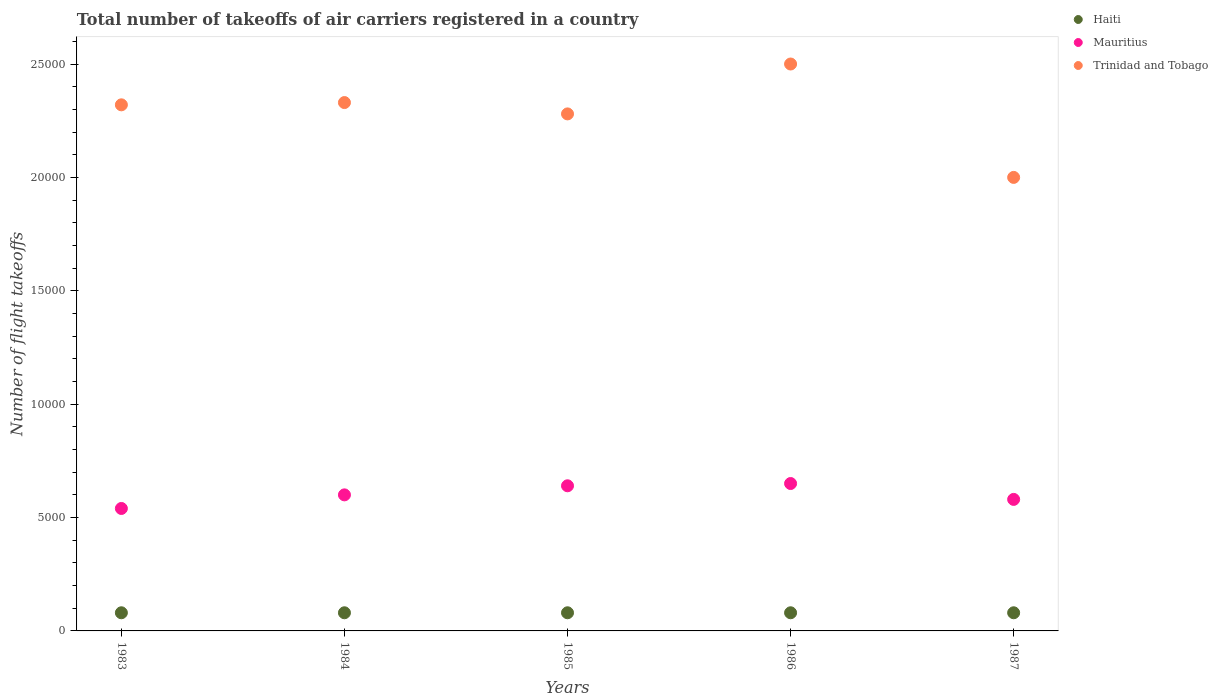How many different coloured dotlines are there?
Give a very brief answer. 3. Is the number of dotlines equal to the number of legend labels?
Your response must be concise. Yes. What is the total number of flight takeoffs in Mauritius in 1986?
Provide a short and direct response. 6500. Across all years, what is the maximum total number of flight takeoffs in Haiti?
Give a very brief answer. 800. Across all years, what is the minimum total number of flight takeoffs in Haiti?
Make the answer very short. 800. In which year was the total number of flight takeoffs in Trinidad and Tobago maximum?
Provide a succinct answer. 1986. What is the total total number of flight takeoffs in Trinidad and Tobago in the graph?
Offer a terse response. 1.14e+05. What is the difference between the total number of flight takeoffs in Haiti in 1985 and the total number of flight takeoffs in Mauritius in 1986?
Your response must be concise. -5700. What is the average total number of flight takeoffs in Mauritius per year?
Offer a terse response. 6020. In the year 1983, what is the difference between the total number of flight takeoffs in Mauritius and total number of flight takeoffs in Haiti?
Give a very brief answer. 4600. What is the ratio of the total number of flight takeoffs in Trinidad and Tobago in 1985 to that in 1987?
Your answer should be compact. 1.14. Is the sum of the total number of flight takeoffs in Haiti in 1984 and 1986 greater than the maximum total number of flight takeoffs in Mauritius across all years?
Offer a very short reply. No. Does the total number of flight takeoffs in Haiti monotonically increase over the years?
Your response must be concise. No. Is the total number of flight takeoffs in Haiti strictly greater than the total number of flight takeoffs in Trinidad and Tobago over the years?
Keep it short and to the point. No. Is the total number of flight takeoffs in Trinidad and Tobago strictly less than the total number of flight takeoffs in Mauritius over the years?
Keep it short and to the point. No. How many years are there in the graph?
Make the answer very short. 5. What is the difference between two consecutive major ticks on the Y-axis?
Your response must be concise. 5000. Does the graph contain grids?
Make the answer very short. No. How many legend labels are there?
Your response must be concise. 3. How are the legend labels stacked?
Your answer should be very brief. Vertical. What is the title of the graph?
Offer a terse response. Total number of takeoffs of air carriers registered in a country. What is the label or title of the X-axis?
Provide a short and direct response. Years. What is the label or title of the Y-axis?
Keep it short and to the point. Number of flight takeoffs. What is the Number of flight takeoffs in Haiti in 1983?
Provide a succinct answer. 800. What is the Number of flight takeoffs of Mauritius in 1983?
Your response must be concise. 5400. What is the Number of flight takeoffs of Trinidad and Tobago in 1983?
Offer a very short reply. 2.32e+04. What is the Number of flight takeoffs in Haiti in 1984?
Your response must be concise. 800. What is the Number of flight takeoffs in Mauritius in 1984?
Your response must be concise. 6000. What is the Number of flight takeoffs of Trinidad and Tobago in 1984?
Your response must be concise. 2.33e+04. What is the Number of flight takeoffs in Haiti in 1985?
Offer a very short reply. 800. What is the Number of flight takeoffs of Mauritius in 1985?
Keep it short and to the point. 6400. What is the Number of flight takeoffs of Trinidad and Tobago in 1985?
Your response must be concise. 2.28e+04. What is the Number of flight takeoffs of Haiti in 1986?
Provide a succinct answer. 800. What is the Number of flight takeoffs in Mauritius in 1986?
Offer a terse response. 6500. What is the Number of flight takeoffs in Trinidad and Tobago in 1986?
Provide a succinct answer. 2.50e+04. What is the Number of flight takeoffs of Haiti in 1987?
Make the answer very short. 800. What is the Number of flight takeoffs in Mauritius in 1987?
Keep it short and to the point. 5800. What is the Number of flight takeoffs in Trinidad and Tobago in 1987?
Ensure brevity in your answer.  2.00e+04. Across all years, what is the maximum Number of flight takeoffs of Haiti?
Provide a succinct answer. 800. Across all years, what is the maximum Number of flight takeoffs of Mauritius?
Offer a very short reply. 6500. Across all years, what is the maximum Number of flight takeoffs in Trinidad and Tobago?
Your response must be concise. 2.50e+04. Across all years, what is the minimum Number of flight takeoffs in Haiti?
Keep it short and to the point. 800. Across all years, what is the minimum Number of flight takeoffs of Mauritius?
Your answer should be very brief. 5400. Across all years, what is the minimum Number of flight takeoffs of Trinidad and Tobago?
Offer a very short reply. 2.00e+04. What is the total Number of flight takeoffs of Haiti in the graph?
Make the answer very short. 4000. What is the total Number of flight takeoffs in Mauritius in the graph?
Provide a succinct answer. 3.01e+04. What is the total Number of flight takeoffs of Trinidad and Tobago in the graph?
Give a very brief answer. 1.14e+05. What is the difference between the Number of flight takeoffs of Haiti in 1983 and that in 1984?
Offer a very short reply. 0. What is the difference between the Number of flight takeoffs of Mauritius in 1983 and that in 1984?
Your response must be concise. -600. What is the difference between the Number of flight takeoffs of Trinidad and Tobago in 1983 and that in 1984?
Provide a short and direct response. -100. What is the difference between the Number of flight takeoffs in Mauritius in 1983 and that in 1985?
Ensure brevity in your answer.  -1000. What is the difference between the Number of flight takeoffs of Haiti in 1983 and that in 1986?
Your answer should be very brief. 0. What is the difference between the Number of flight takeoffs of Mauritius in 1983 and that in 1986?
Provide a succinct answer. -1100. What is the difference between the Number of flight takeoffs of Trinidad and Tobago in 1983 and that in 1986?
Ensure brevity in your answer.  -1800. What is the difference between the Number of flight takeoffs of Haiti in 1983 and that in 1987?
Give a very brief answer. 0. What is the difference between the Number of flight takeoffs in Mauritius in 1983 and that in 1987?
Give a very brief answer. -400. What is the difference between the Number of flight takeoffs of Trinidad and Tobago in 1983 and that in 1987?
Your answer should be compact. 3200. What is the difference between the Number of flight takeoffs in Mauritius in 1984 and that in 1985?
Provide a short and direct response. -400. What is the difference between the Number of flight takeoffs in Haiti in 1984 and that in 1986?
Offer a very short reply. 0. What is the difference between the Number of flight takeoffs of Mauritius in 1984 and that in 1986?
Offer a very short reply. -500. What is the difference between the Number of flight takeoffs in Trinidad and Tobago in 1984 and that in 1986?
Ensure brevity in your answer.  -1700. What is the difference between the Number of flight takeoffs in Haiti in 1984 and that in 1987?
Offer a terse response. 0. What is the difference between the Number of flight takeoffs in Trinidad and Tobago in 1984 and that in 1987?
Keep it short and to the point. 3300. What is the difference between the Number of flight takeoffs of Haiti in 1985 and that in 1986?
Make the answer very short. 0. What is the difference between the Number of flight takeoffs in Mauritius in 1985 and that in 1986?
Offer a terse response. -100. What is the difference between the Number of flight takeoffs in Trinidad and Tobago in 1985 and that in 1986?
Your answer should be compact. -2200. What is the difference between the Number of flight takeoffs of Mauritius in 1985 and that in 1987?
Your answer should be compact. 600. What is the difference between the Number of flight takeoffs in Trinidad and Tobago in 1985 and that in 1987?
Provide a succinct answer. 2800. What is the difference between the Number of flight takeoffs of Haiti in 1986 and that in 1987?
Provide a succinct answer. 0. What is the difference between the Number of flight takeoffs of Mauritius in 1986 and that in 1987?
Make the answer very short. 700. What is the difference between the Number of flight takeoffs in Trinidad and Tobago in 1986 and that in 1987?
Provide a short and direct response. 5000. What is the difference between the Number of flight takeoffs in Haiti in 1983 and the Number of flight takeoffs in Mauritius in 1984?
Your answer should be very brief. -5200. What is the difference between the Number of flight takeoffs of Haiti in 1983 and the Number of flight takeoffs of Trinidad and Tobago in 1984?
Provide a succinct answer. -2.25e+04. What is the difference between the Number of flight takeoffs of Mauritius in 1983 and the Number of flight takeoffs of Trinidad and Tobago in 1984?
Keep it short and to the point. -1.79e+04. What is the difference between the Number of flight takeoffs of Haiti in 1983 and the Number of flight takeoffs of Mauritius in 1985?
Offer a terse response. -5600. What is the difference between the Number of flight takeoffs of Haiti in 1983 and the Number of flight takeoffs of Trinidad and Tobago in 1985?
Ensure brevity in your answer.  -2.20e+04. What is the difference between the Number of flight takeoffs of Mauritius in 1983 and the Number of flight takeoffs of Trinidad and Tobago in 1985?
Keep it short and to the point. -1.74e+04. What is the difference between the Number of flight takeoffs of Haiti in 1983 and the Number of flight takeoffs of Mauritius in 1986?
Ensure brevity in your answer.  -5700. What is the difference between the Number of flight takeoffs in Haiti in 1983 and the Number of flight takeoffs in Trinidad and Tobago in 1986?
Offer a terse response. -2.42e+04. What is the difference between the Number of flight takeoffs of Mauritius in 1983 and the Number of flight takeoffs of Trinidad and Tobago in 1986?
Your answer should be compact. -1.96e+04. What is the difference between the Number of flight takeoffs of Haiti in 1983 and the Number of flight takeoffs of Mauritius in 1987?
Your answer should be very brief. -5000. What is the difference between the Number of flight takeoffs in Haiti in 1983 and the Number of flight takeoffs in Trinidad and Tobago in 1987?
Your response must be concise. -1.92e+04. What is the difference between the Number of flight takeoffs of Mauritius in 1983 and the Number of flight takeoffs of Trinidad and Tobago in 1987?
Your answer should be very brief. -1.46e+04. What is the difference between the Number of flight takeoffs of Haiti in 1984 and the Number of flight takeoffs of Mauritius in 1985?
Your response must be concise. -5600. What is the difference between the Number of flight takeoffs in Haiti in 1984 and the Number of flight takeoffs in Trinidad and Tobago in 1985?
Offer a very short reply. -2.20e+04. What is the difference between the Number of flight takeoffs in Mauritius in 1984 and the Number of flight takeoffs in Trinidad and Tobago in 1985?
Keep it short and to the point. -1.68e+04. What is the difference between the Number of flight takeoffs in Haiti in 1984 and the Number of flight takeoffs in Mauritius in 1986?
Make the answer very short. -5700. What is the difference between the Number of flight takeoffs in Haiti in 1984 and the Number of flight takeoffs in Trinidad and Tobago in 1986?
Keep it short and to the point. -2.42e+04. What is the difference between the Number of flight takeoffs of Mauritius in 1984 and the Number of flight takeoffs of Trinidad and Tobago in 1986?
Make the answer very short. -1.90e+04. What is the difference between the Number of flight takeoffs of Haiti in 1984 and the Number of flight takeoffs of Mauritius in 1987?
Provide a short and direct response. -5000. What is the difference between the Number of flight takeoffs in Haiti in 1984 and the Number of flight takeoffs in Trinidad and Tobago in 1987?
Offer a very short reply. -1.92e+04. What is the difference between the Number of flight takeoffs in Mauritius in 1984 and the Number of flight takeoffs in Trinidad and Tobago in 1987?
Your answer should be compact. -1.40e+04. What is the difference between the Number of flight takeoffs in Haiti in 1985 and the Number of flight takeoffs in Mauritius in 1986?
Provide a succinct answer. -5700. What is the difference between the Number of flight takeoffs in Haiti in 1985 and the Number of flight takeoffs in Trinidad and Tobago in 1986?
Keep it short and to the point. -2.42e+04. What is the difference between the Number of flight takeoffs of Mauritius in 1985 and the Number of flight takeoffs of Trinidad and Tobago in 1986?
Make the answer very short. -1.86e+04. What is the difference between the Number of flight takeoffs in Haiti in 1985 and the Number of flight takeoffs in Mauritius in 1987?
Provide a succinct answer. -5000. What is the difference between the Number of flight takeoffs of Haiti in 1985 and the Number of flight takeoffs of Trinidad and Tobago in 1987?
Ensure brevity in your answer.  -1.92e+04. What is the difference between the Number of flight takeoffs in Mauritius in 1985 and the Number of flight takeoffs in Trinidad and Tobago in 1987?
Your answer should be very brief. -1.36e+04. What is the difference between the Number of flight takeoffs of Haiti in 1986 and the Number of flight takeoffs of Mauritius in 1987?
Make the answer very short. -5000. What is the difference between the Number of flight takeoffs of Haiti in 1986 and the Number of flight takeoffs of Trinidad and Tobago in 1987?
Give a very brief answer. -1.92e+04. What is the difference between the Number of flight takeoffs in Mauritius in 1986 and the Number of flight takeoffs in Trinidad and Tobago in 1987?
Keep it short and to the point. -1.35e+04. What is the average Number of flight takeoffs of Haiti per year?
Provide a succinct answer. 800. What is the average Number of flight takeoffs of Mauritius per year?
Offer a terse response. 6020. What is the average Number of flight takeoffs of Trinidad and Tobago per year?
Ensure brevity in your answer.  2.29e+04. In the year 1983, what is the difference between the Number of flight takeoffs in Haiti and Number of flight takeoffs in Mauritius?
Your response must be concise. -4600. In the year 1983, what is the difference between the Number of flight takeoffs of Haiti and Number of flight takeoffs of Trinidad and Tobago?
Provide a short and direct response. -2.24e+04. In the year 1983, what is the difference between the Number of flight takeoffs of Mauritius and Number of flight takeoffs of Trinidad and Tobago?
Your response must be concise. -1.78e+04. In the year 1984, what is the difference between the Number of flight takeoffs of Haiti and Number of flight takeoffs of Mauritius?
Your answer should be compact. -5200. In the year 1984, what is the difference between the Number of flight takeoffs of Haiti and Number of flight takeoffs of Trinidad and Tobago?
Your answer should be very brief. -2.25e+04. In the year 1984, what is the difference between the Number of flight takeoffs of Mauritius and Number of flight takeoffs of Trinidad and Tobago?
Ensure brevity in your answer.  -1.73e+04. In the year 1985, what is the difference between the Number of flight takeoffs of Haiti and Number of flight takeoffs of Mauritius?
Give a very brief answer. -5600. In the year 1985, what is the difference between the Number of flight takeoffs in Haiti and Number of flight takeoffs in Trinidad and Tobago?
Provide a succinct answer. -2.20e+04. In the year 1985, what is the difference between the Number of flight takeoffs of Mauritius and Number of flight takeoffs of Trinidad and Tobago?
Your response must be concise. -1.64e+04. In the year 1986, what is the difference between the Number of flight takeoffs in Haiti and Number of flight takeoffs in Mauritius?
Your response must be concise. -5700. In the year 1986, what is the difference between the Number of flight takeoffs in Haiti and Number of flight takeoffs in Trinidad and Tobago?
Your response must be concise. -2.42e+04. In the year 1986, what is the difference between the Number of flight takeoffs of Mauritius and Number of flight takeoffs of Trinidad and Tobago?
Ensure brevity in your answer.  -1.85e+04. In the year 1987, what is the difference between the Number of flight takeoffs in Haiti and Number of flight takeoffs in Mauritius?
Keep it short and to the point. -5000. In the year 1987, what is the difference between the Number of flight takeoffs of Haiti and Number of flight takeoffs of Trinidad and Tobago?
Make the answer very short. -1.92e+04. In the year 1987, what is the difference between the Number of flight takeoffs in Mauritius and Number of flight takeoffs in Trinidad and Tobago?
Make the answer very short. -1.42e+04. What is the ratio of the Number of flight takeoffs in Haiti in 1983 to that in 1984?
Provide a succinct answer. 1. What is the ratio of the Number of flight takeoffs in Mauritius in 1983 to that in 1984?
Your response must be concise. 0.9. What is the ratio of the Number of flight takeoffs of Trinidad and Tobago in 1983 to that in 1984?
Keep it short and to the point. 1. What is the ratio of the Number of flight takeoffs of Mauritius in 1983 to that in 1985?
Give a very brief answer. 0.84. What is the ratio of the Number of flight takeoffs in Trinidad and Tobago in 1983 to that in 1985?
Offer a terse response. 1.02. What is the ratio of the Number of flight takeoffs of Haiti in 1983 to that in 1986?
Give a very brief answer. 1. What is the ratio of the Number of flight takeoffs of Mauritius in 1983 to that in 1986?
Your response must be concise. 0.83. What is the ratio of the Number of flight takeoffs of Trinidad and Tobago in 1983 to that in 1986?
Keep it short and to the point. 0.93. What is the ratio of the Number of flight takeoffs in Trinidad and Tobago in 1983 to that in 1987?
Give a very brief answer. 1.16. What is the ratio of the Number of flight takeoffs in Mauritius in 1984 to that in 1985?
Your answer should be very brief. 0.94. What is the ratio of the Number of flight takeoffs of Trinidad and Tobago in 1984 to that in 1985?
Ensure brevity in your answer.  1.02. What is the ratio of the Number of flight takeoffs of Haiti in 1984 to that in 1986?
Your answer should be very brief. 1. What is the ratio of the Number of flight takeoffs of Trinidad and Tobago in 1984 to that in 1986?
Your answer should be compact. 0.93. What is the ratio of the Number of flight takeoffs in Mauritius in 1984 to that in 1987?
Your answer should be very brief. 1.03. What is the ratio of the Number of flight takeoffs of Trinidad and Tobago in 1984 to that in 1987?
Your answer should be compact. 1.17. What is the ratio of the Number of flight takeoffs of Haiti in 1985 to that in 1986?
Provide a succinct answer. 1. What is the ratio of the Number of flight takeoffs of Mauritius in 1985 to that in 1986?
Offer a very short reply. 0.98. What is the ratio of the Number of flight takeoffs in Trinidad and Tobago in 1985 to that in 1986?
Ensure brevity in your answer.  0.91. What is the ratio of the Number of flight takeoffs in Mauritius in 1985 to that in 1987?
Offer a terse response. 1.1. What is the ratio of the Number of flight takeoffs in Trinidad and Tobago in 1985 to that in 1987?
Your answer should be compact. 1.14. What is the ratio of the Number of flight takeoffs of Haiti in 1986 to that in 1987?
Your answer should be compact. 1. What is the ratio of the Number of flight takeoffs in Mauritius in 1986 to that in 1987?
Offer a very short reply. 1.12. What is the difference between the highest and the second highest Number of flight takeoffs of Haiti?
Provide a short and direct response. 0. What is the difference between the highest and the second highest Number of flight takeoffs in Mauritius?
Offer a terse response. 100. What is the difference between the highest and the second highest Number of flight takeoffs of Trinidad and Tobago?
Keep it short and to the point. 1700. What is the difference between the highest and the lowest Number of flight takeoffs of Haiti?
Make the answer very short. 0. What is the difference between the highest and the lowest Number of flight takeoffs of Mauritius?
Provide a succinct answer. 1100. What is the difference between the highest and the lowest Number of flight takeoffs in Trinidad and Tobago?
Your answer should be very brief. 5000. 